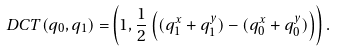<formula> <loc_0><loc_0><loc_500><loc_500>\ D C T ( q _ { 0 } , q _ { 1 } ) = & \left ( 1 , \frac { 1 } { 2 } \left ( ( q _ { 1 } ^ { x } + q _ { 1 } ^ { y } ) - ( q _ { 0 } ^ { x } + q _ { 0 } ^ { y } ) \right ) \right ) .</formula> 